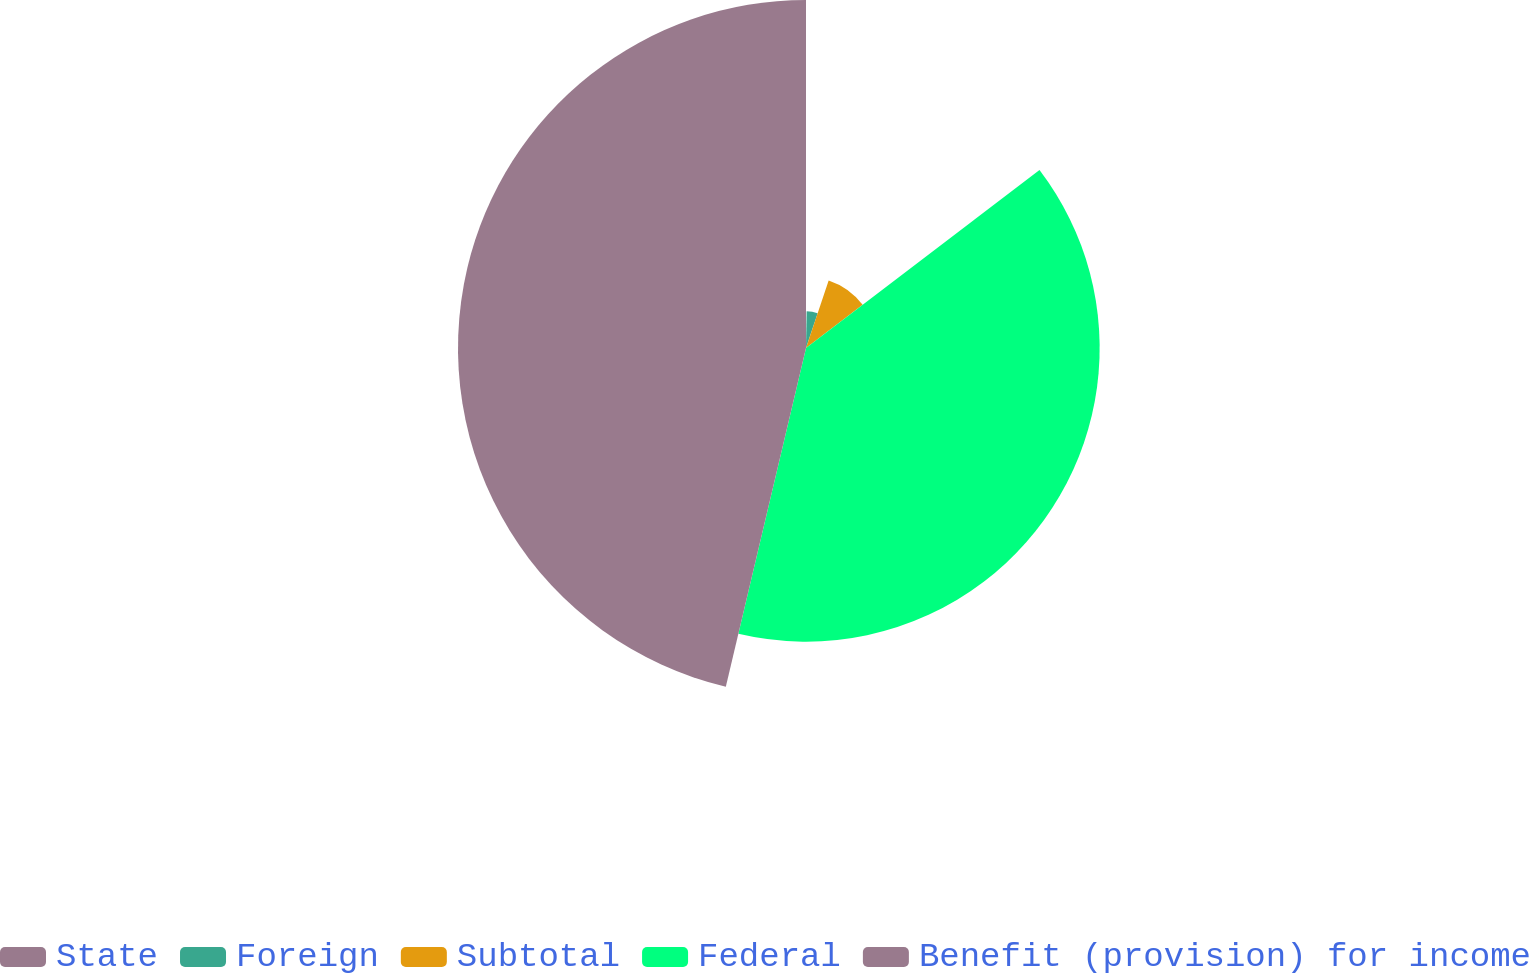Convert chart. <chart><loc_0><loc_0><loc_500><loc_500><pie_chart><fcel>State<fcel>Foreign<fcel>Subtotal<fcel>Federal<fcel>Benefit (provision) for income<nl><fcel>0.27%<fcel>4.88%<fcel>9.48%<fcel>39.07%<fcel>46.3%<nl></chart> 